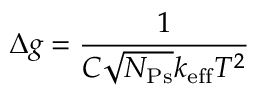Convert formula to latex. <formula><loc_0><loc_0><loc_500><loc_500>\Delta g = \frac { 1 } { C \sqrt { N _ { P s } } k _ { e f f } T ^ { 2 } }</formula> 